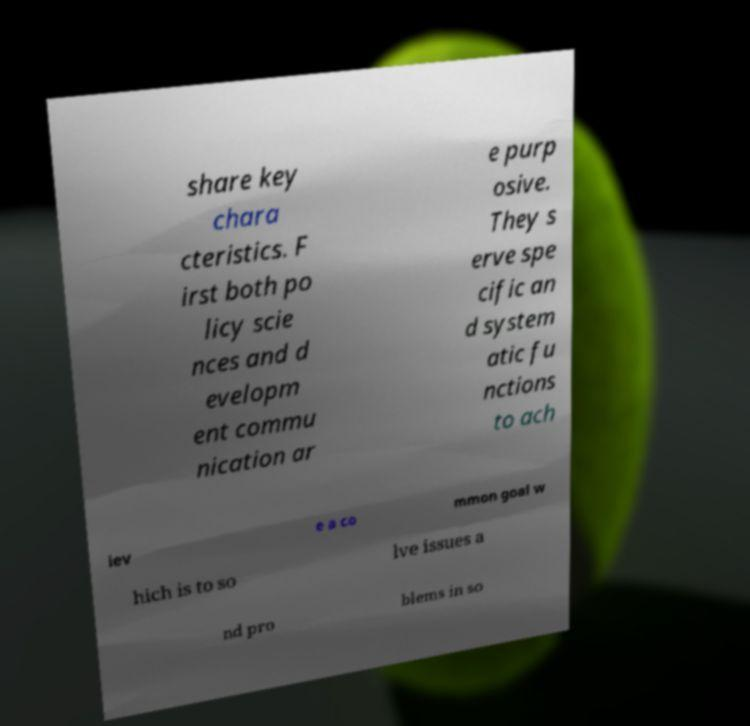What messages or text are displayed in this image? I need them in a readable, typed format. share key chara cteristics. F irst both po licy scie nces and d evelopm ent commu nication ar e purp osive. They s erve spe cific an d system atic fu nctions to ach iev e a co mmon goal w hich is to so lve issues a nd pro blems in so 